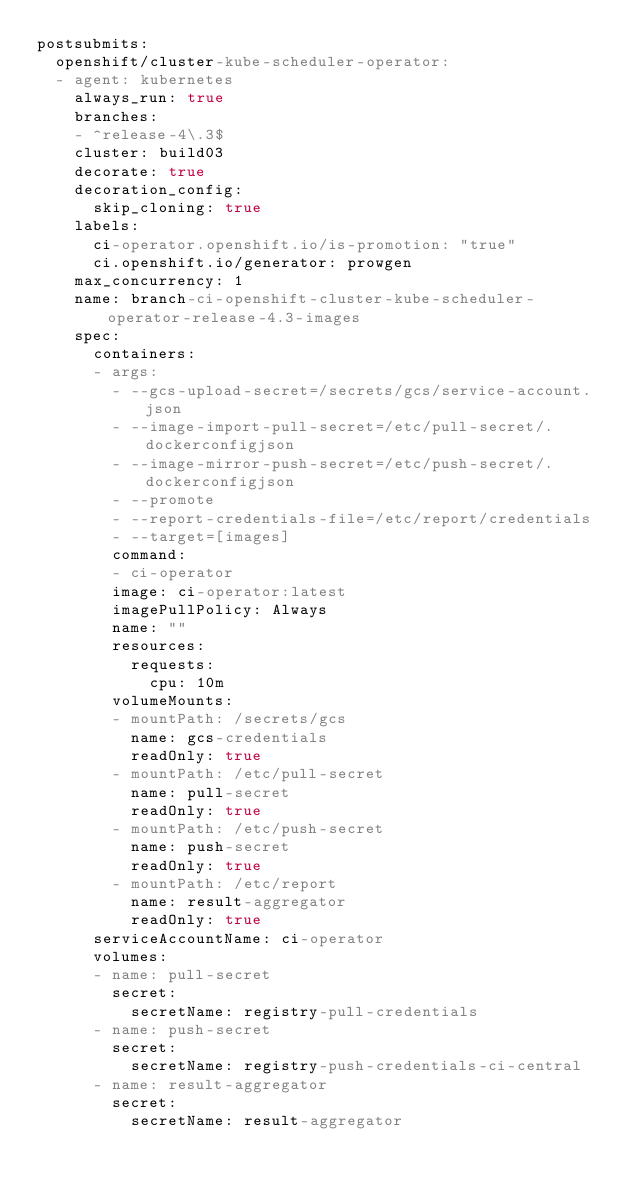<code> <loc_0><loc_0><loc_500><loc_500><_YAML_>postsubmits:
  openshift/cluster-kube-scheduler-operator:
  - agent: kubernetes
    always_run: true
    branches:
    - ^release-4\.3$
    cluster: build03
    decorate: true
    decoration_config:
      skip_cloning: true
    labels:
      ci-operator.openshift.io/is-promotion: "true"
      ci.openshift.io/generator: prowgen
    max_concurrency: 1
    name: branch-ci-openshift-cluster-kube-scheduler-operator-release-4.3-images
    spec:
      containers:
      - args:
        - --gcs-upload-secret=/secrets/gcs/service-account.json
        - --image-import-pull-secret=/etc/pull-secret/.dockerconfigjson
        - --image-mirror-push-secret=/etc/push-secret/.dockerconfigjson
        - --promote
        - --report-credentials-file=/etc/report/credentials
        - --target=[images]
        command:
        - ci-operator
        image: ci-operator:latest
        imagePullPolicy: Always
        name: ""
        resources:
          requests:
            cpu: 10m
        volumeMounts:
        - mountPath: /secrets/gcs
          name: gcs-credentials
          readOnly: true
        - mountPath: /etc/pull-secret
          name: pull-secret
          readOnly: true
        - mountPath: /etc/push-secret
          name: push-secret
          readOnly: true
        - mountPath: /etc/report
          name: result-aggregator
          readOnly: true
      serviceAccountName: ci-operator
      volumes:
      - name: pull-secret
        secret:
          secretName: registry-pull-credentials
      - name: push-secret
        secret:
          secretName: registry-push-credentials-ci-central
      - name: result-aggregator
        secret:
          secretName: result-aggregator
</code> 